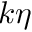Convert formula to latex. <formula><loc_0><loc_0><loc_500><loc_500>k \eta</formula> 